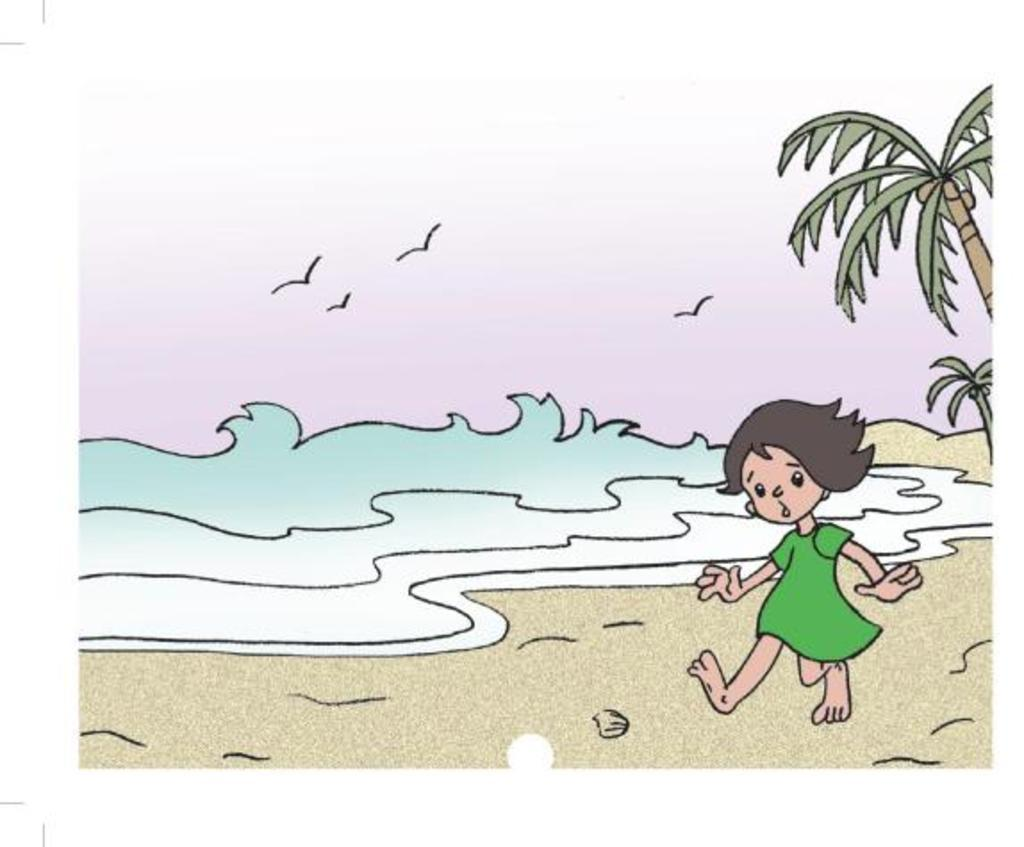What type of image is shown in the picture? The image is a drawing. What is the main subject of the drawing? The drawing depicts a cartoon girl. Where is the cartoon girl located in the drawing? The cartoon girl is on the beach side. What color is the sock worn by the cartoon girl in the drawing? There is no sock mentioned or visible in the drawing; the cartoon girl is not wearing any socks. 